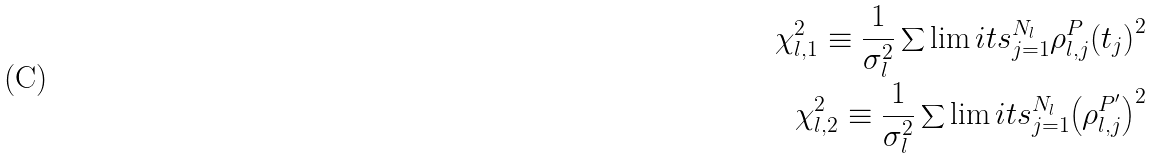<formula> <loc_0><loc_0><loc_500><loc_500>\chi _ { l , 1 } ^ { 2 } \equiv \frac { 1 } { \sigma _ { l } ^ { 2 } } \sum \lim i t s _ { j = 1 } ^ { N _ { l } } \rho _ { l , j } ^ { P } { \left ( t _ { j } \right ) } ^ { 2 } \\ \chi _ { l , 2 } ^ { 2 } \equiv \frac { 1 } { \sigma _ { l } ^ { 2 } } \sum \lim i t s _ { j = 1 } ^ { N _ { l } } { \left ( \rho _ { l , j } ^ { P ^ { \prime } } \right ) } ^ { 2 }</formula> 